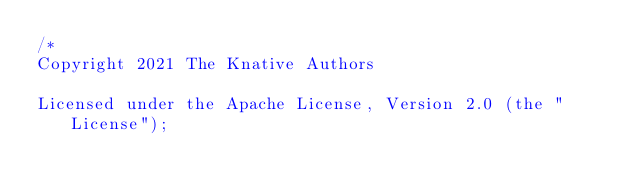Convert code to text. <code><loc_0><loc_0><loc_500><loc_500><_Go_>/*
Copyright 2021 The Knative Authors

Licensed under the Apache License, Version 2.0 (the "License");</code> 